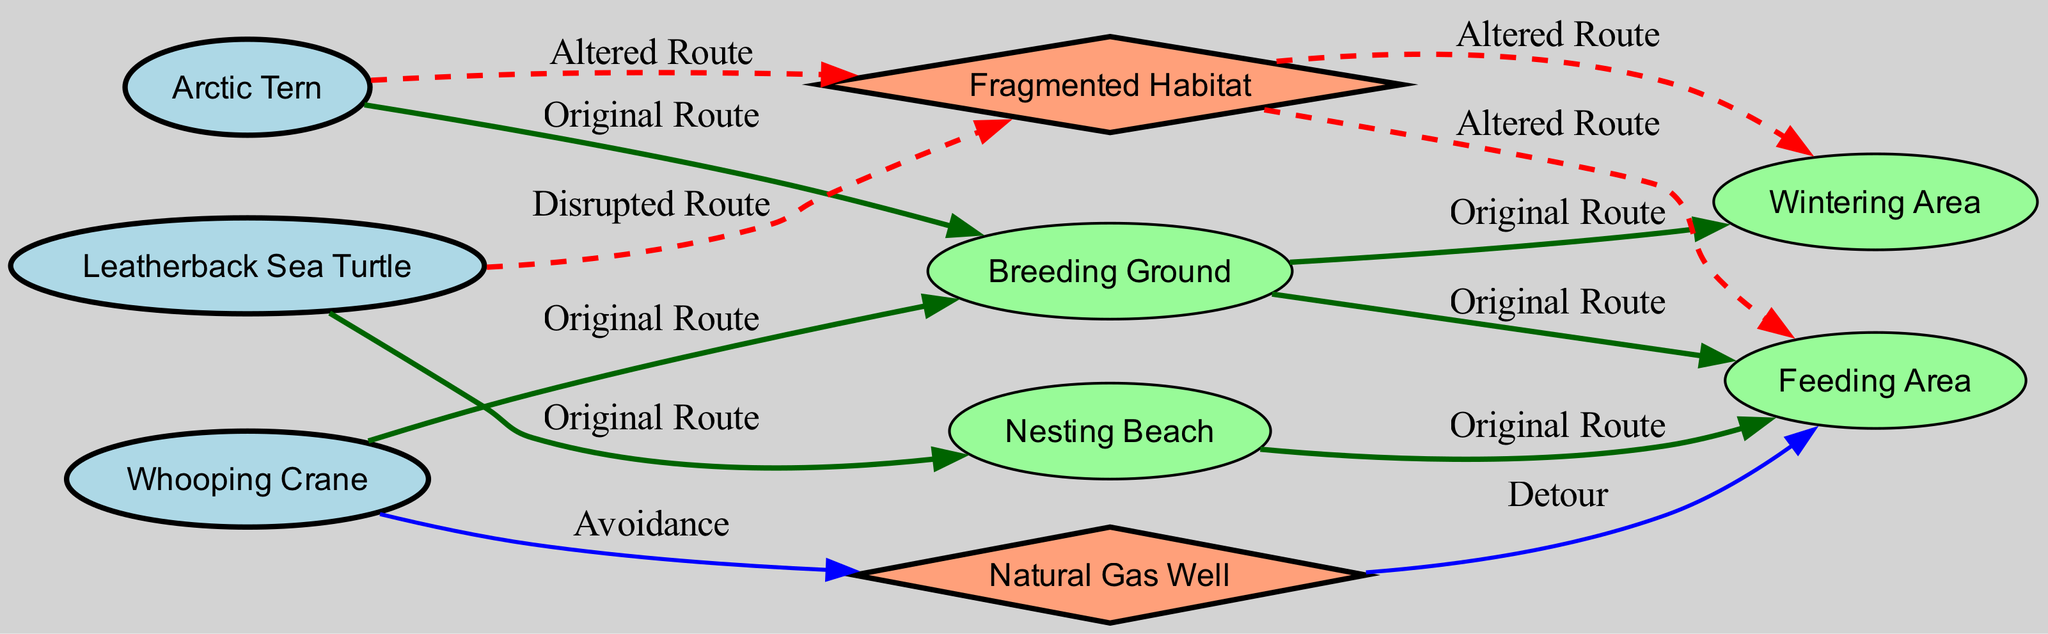What species follows the "Original Route" to the Feeding Area? The diagram shows that the Whooping Crane follows the original route to the Feeding Area. This is directly indicated by the edge labeled "Original Route" connecting the Breeding Ground to the Feeding Area, which is the last step in the route for this species.
Answer: Whooping Crane How many edges connect directly to the Natural Gas Well? By examining the diagram, there are two edges connected to the Natural Gas Well: one represents the avoidance behavior of the Whooping Crane and the other represents a detour to the Feeding Area. Thus, the total count of edges connected to the Natural Gas Well is two.
Answer: 2 What is the final destination of the Arctic Tern after its altered route? The altered route of the Arctic Tern leads from the Fragmented Habitat to the Wintering Area. Therefore, if we follow the path indicated in the diagram, the final destination for the Arctic Tern after its altered route is the Wintering Area.
Answer: Wintering Area Which species has a disrupted route leading to the Fragmented Habitat? In the diagram, the Leatherback Sea Turtle has a disrupted route leading to the Fragmented Habitat. This is shown by the edge labeled "Disrupted Route" connecting the Leatherback Sea Turtle to the Fragmented Habitat.
Answer: Leatherback Sea Turtle What color are the nodes representing the birds? The nodes representing the birds, namely the Arctic Tern, Whooping Crane, and Leatherback Sea Turtle, are filled with light blue as indicated by the styles assigned to these specific nodes in the graph.
Answer: Light blue Which route has been affected for the Arctic Tern in terms of migration? The original route of the Arctic Tern to the Wintering Area has been altered due to habitat fragmentation. The diagram specifically notes this change with edges labeled "Altered Route," indicating that its path has been modified.
Answer: Altered Route What type of route does the Whooping Crane take to avoid the Natural Gas Well? The route taken by the Whooping Crane to avoid the Natural Gas Well is labeled as "Avoidance." This edge directly indicates the behavior of the crane in relation to the well, confirming the avoidance strategy.
Answer: Avoidance How many original routes are directed to the Breeding Ground? The diagram shows that both the Arctic Tern and the Whooping Crane have original routes that lead to the Breeding Ground. This means there are two original routes directed towards this node.
Answer: 2 What kind of edges are used to represent "Altered Route" connections? In the diagram, connections labeled as "Altered Route" are represented by red dashed edges. This formatting indicates the type of pathways that have been compromised due to habitat disruption.
Answer: Red dashed edges 